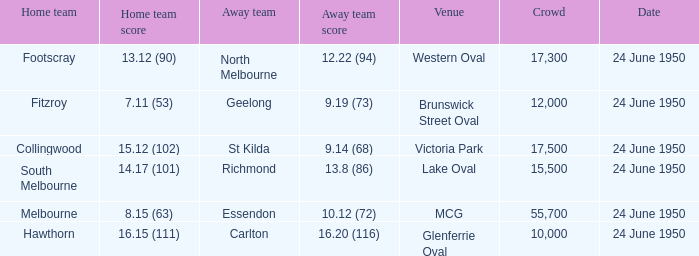When was the game where the away team had a score of 13.8 (86)? 24 June 1950. 